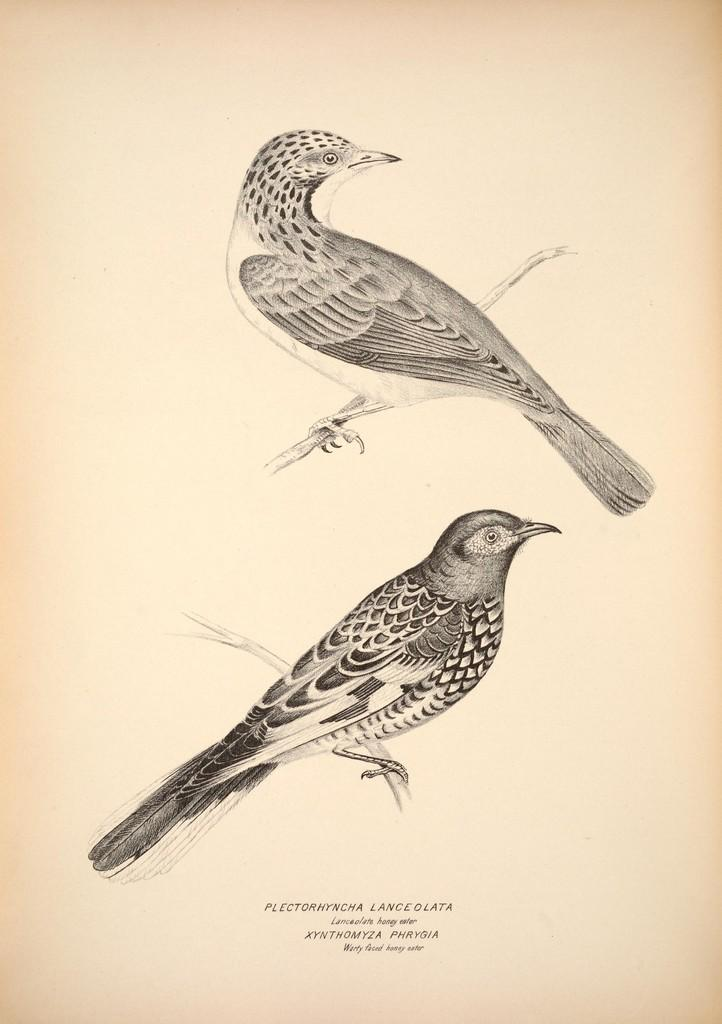What is present in the image? There is a paper in the image. What is depicted on the paper? The paper has bird paintings on it. What type of list can be seen on the plate in the image? There is no plate or list present in the image; it only features a paper with bird paintings. 